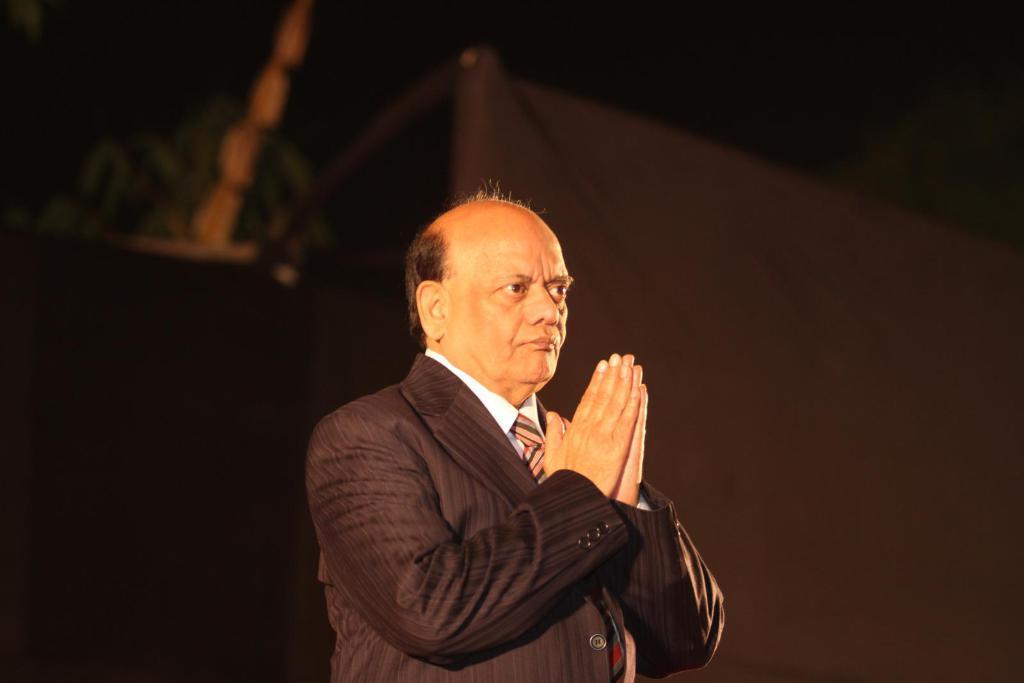How would you summarize this image in a sentence or two? In this picture I can see in the middle there is a man, he is wearing the coat, tie, shirt. He is joining his both hands. 